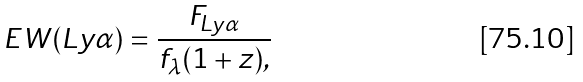<formula> <loc_0><loc_0><loc_500><loc_500>E W ( L y \alpha ) = \frac { F _ { L y \alpha } } { f _ { \lambda } ( 1 + z ) , }</formula> 